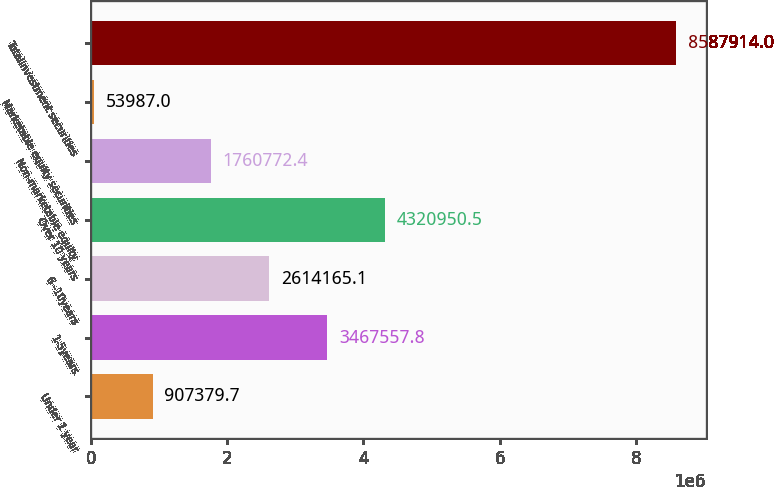<chart> <loc_0><loc_0><loc_500><loc_500><bar_chart><fcel>Under 1 year<fcel>1-5years<fcel>6 -10years<fcel>Over 10 years<fcel>Non-marketable equity<fcel>Marketable equity securities<fcel>Totalinvestment securities<nl><fcel>907380<fcel>3.46756e+06<fcel>2.61417e+06<fcel>4.32095e+06<fcel>1.76077e+06<fcel>53987<fcel>8.58791e+06<nl></chart> 